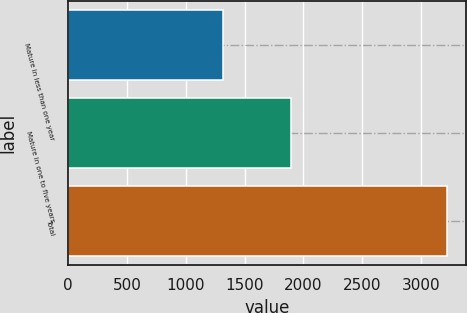Convert chart to OTSL. <chart><loc_0><loc_0><loc_500><loc_500><bar_chart><fcel>Mature in less than one year<fcel>Mature in one to five years<fcel>Total<nl><fcel>1320.7<fcel>1898.3<fcel>3219<nl></chart> 